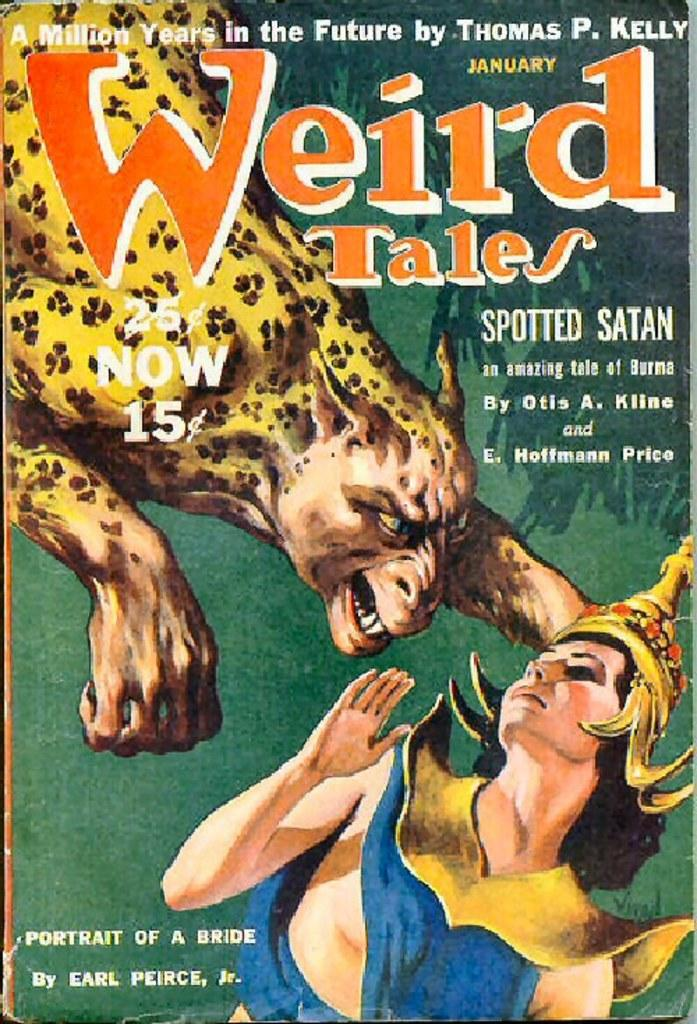<image>
Give a short and clear explanation of the subsequent image. A book called Weird Tales shows a demonic cheetah going after a woman on the cover 